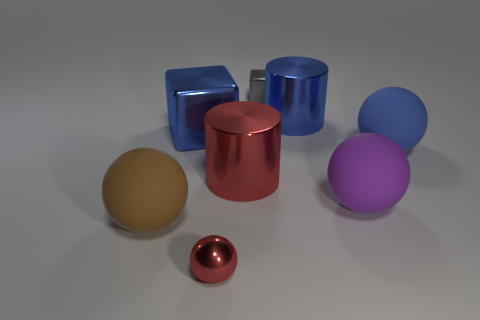Subtract all gray spheres. Subtract all green cylinders. How many spheres are left? 4 Add 1 big blocks. How many objects exist? 9 Subtract all blocks. How many objects are left? 6 Subtract all big gray rubber spheres. Subtract all metal cylinders. How many objects are left? 6 Add 2 tiny gray metallic cubes. How many tiny gray metallic cubes are left? 3 Add 5 large red objects. How many large red objects exist? 6 Subtract 0 yellow blocks. How many objects are left? 8 